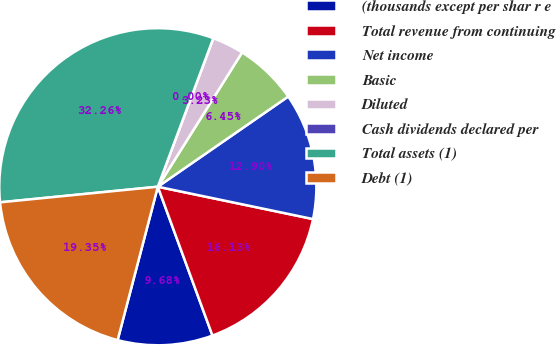<chart> <loc_0><loc_0><loc_500><loc_500><pie_chart><fcel>(thousands except per shar r e<fcel>Total revenue from continuing<fcel>Net income<fcel>Basic<fcel>Diluted<fcel>Cash dividends declared per<fcel>Total assets (1)<fcel>Debt (1)<nl><fcel>9.68%<fcel>16.13%<fcel>12.9%<fcel>6.45%<fcel>3.23%<fcel>0.0%<fcel>32.26%<fcel>19.35%<nl></chart> 